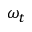<formula> <loc_0><loc_0><loc_500><loc_500>\omega _ { t }</formula> 